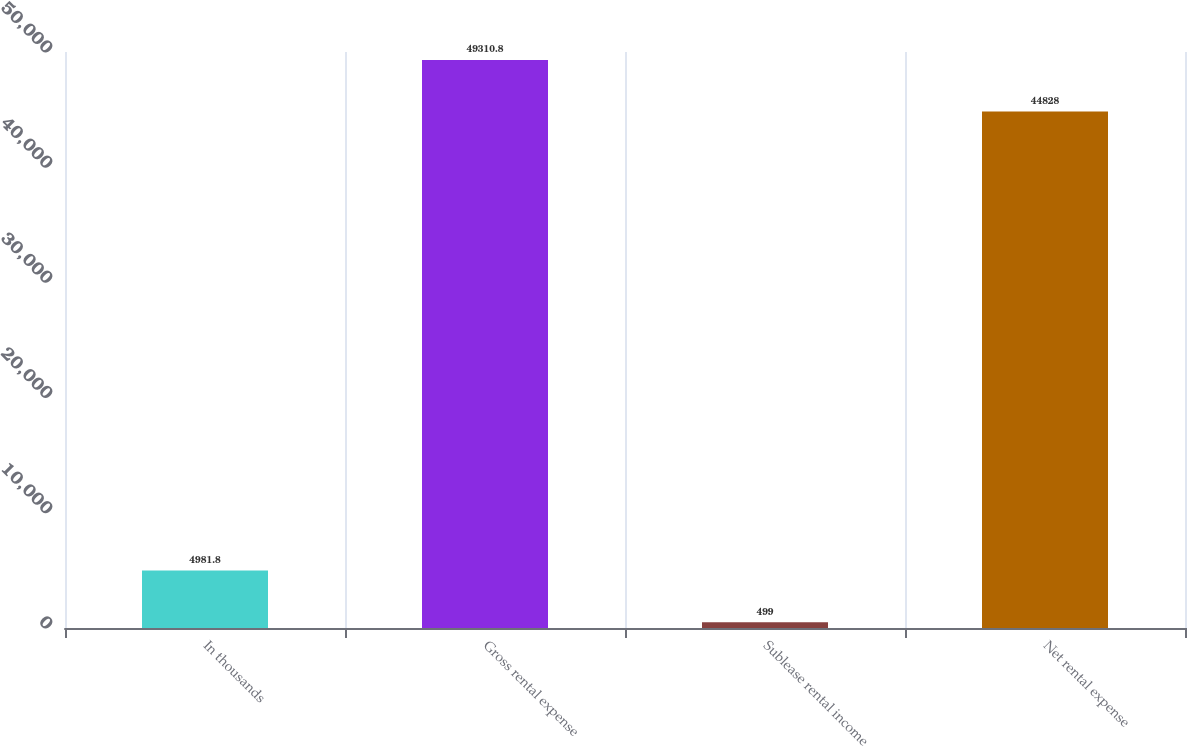Convert chart. <chart><loc_0><loc_0><loc_500><loc_500><bar_chart><fcel>In thousands<fcel>Gross rental expense<fcel>Sublease rental income<fcel>Net rental expense<nl><fcel>4981.8<fcel>49310.8<fcel>499<fcel>44828<nl></chart> 